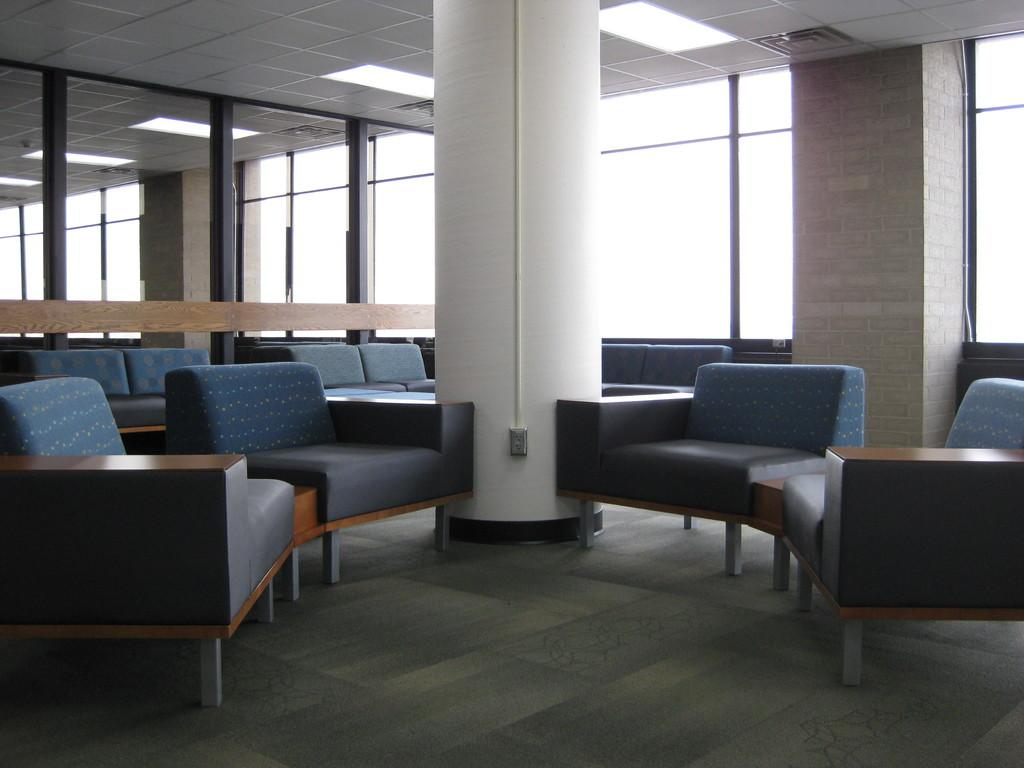What type of structure is present in the image? There is a building in the image. What type of furniture can be seen on the floor? There are sofa sets on the floor. What is visible on the right side of the image? There is a wall visible on the right side of the image. What feature allows natural light to enter the building? There is a window visible in the middle of the image. How many rabbits are sitting on the sofa sets in the image? There are no rabbits present in the image; only sofa sets can be seen on the floor. 